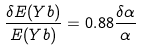Convert formula to latex. <formula><loc_0><loc_0><loc_500><loc_500>\frac { \delta E ( Y b ) } { E ( Y b ) } = 0 . 8 8 \frac { \delta \alpha } { \alpha }</formula> 